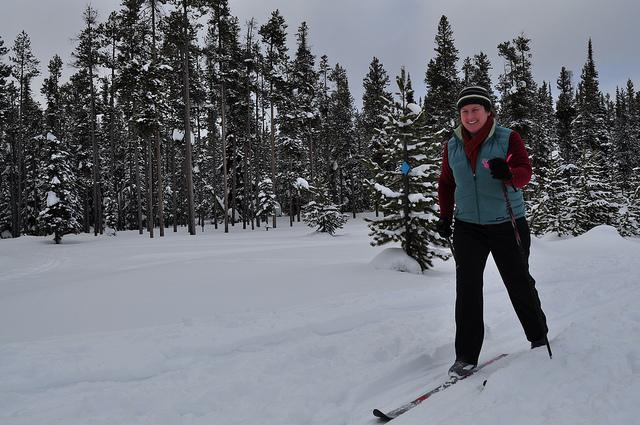Is the man skiing?
Concise answer only. Yes. Is her coat open?
Give a very brief answer. No. Is there a shadow of the man?
Concise answer only. No. What color is the adult's outfit?
Write a very short answer. Blue. What symbol is on the skiers' chest?
Be succinct. Can't see. What is the man holding in his left arm?
Write a very short answer. Ski pole. How many people?
Answer briefly. 1. Is the man wearing a scarf?
Be succinct. No. Is it a warm day?
Be succinct. No. What color is the man's vest?
Write a very short answer. Blue. Is she competing?
Be succinct. No. Is this a sunny day?
Keep it brief. No. 